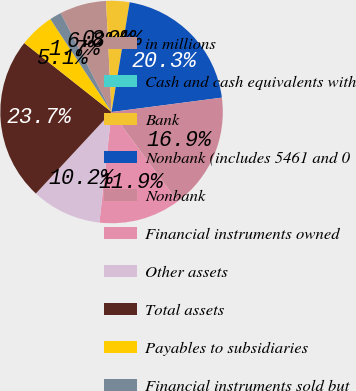Convert chart to OTSL. <chart><loc_0><loc_0><loc_500><loc_500><pie_chart><fcel>in millions<fcel>Cash and cash equivalents with<fcel>Bank<fcel>Nonbank (includes 5461 and 0<fcel>Nonbank<fcel>Financial instruments owned<fcel>Other assets<fcel>Total assets<fcel>Payables to subsidiaries<fcel>Financial instruments sold but<nl><fcel>6.78%<fcel>0.0%<fcel>3.39%<fcel>20.34%<fcel>16.95%<fcel>11.86%<fcel>10.17%<fcel>23.73%<fcel>5.09%<fcel>1.7%<nl></chart> 